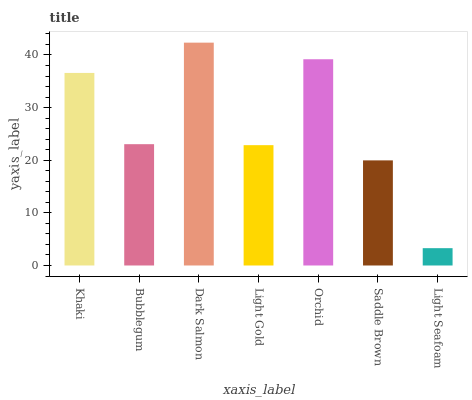Is Light Seafoam the minimum?
Answer yes or no. Yes. Is Dark Salmon the maximum?
Answer yes or no. Yes. Is Bubblegum the minimum?
Answer yes or no. No. Is Bubblegum the maximum?
Answer yes or no. No. Is Khaki greater than Bubblegum?
Answer yes or no. Yes. Is Bubblegum less than Khaki?
Answer yes or no. Yes. Is Bubblegum greater than Khaki?
Answer yes or no. No. Is Khaki less than Bubblegum?
Answer yes or no. No. Is Bubblegum the high median?
Answer yes or no. Yes. Is Bubblegum the low median?
Answer yes or no. Yes. Is Orchid the high median?
Answer yes or no. No. Is Light Seafoam the low median?
Answer yes or no. No. 